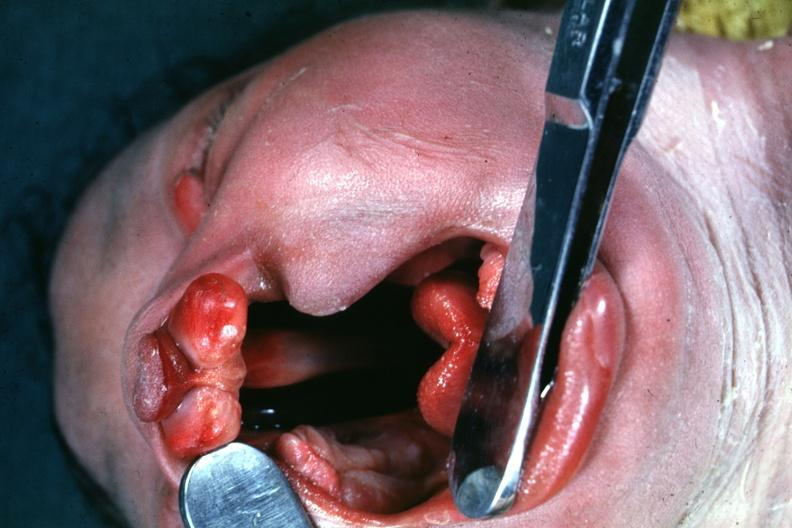what is present?
Answer the question using a single word or phrase. Face 